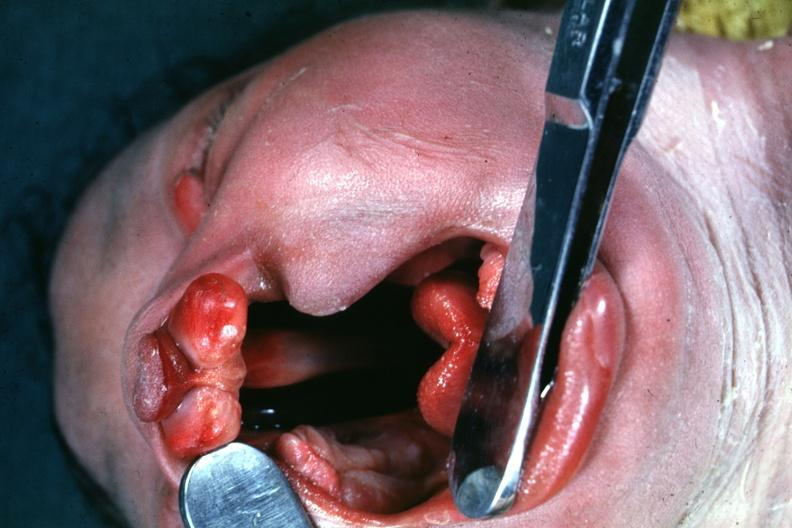what is present?
Answer the question using a single word or phrase. Face 